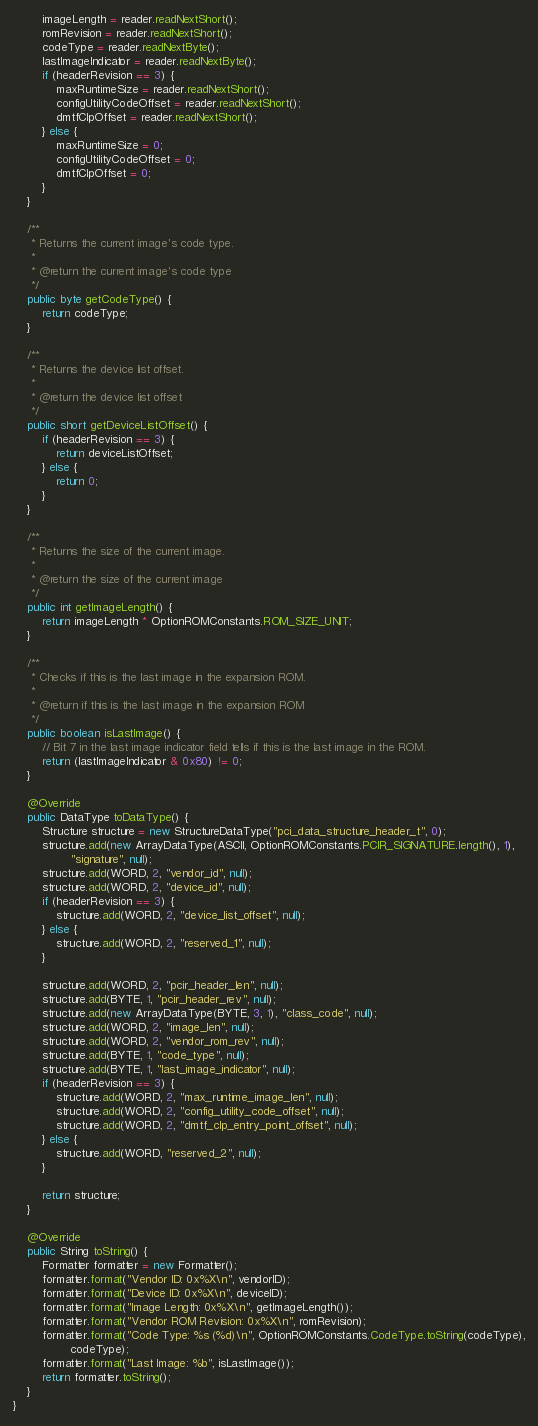Convert code to text. <code><loc_0><loc_0><loc_500><loc_500><_Java_>		imageLength = reader.readNextShort();
		romRevision = reader.readNextShort();
		codeType = reader.readNextByte();
		lastImageIndicator = reader.readNextByte();
		if (headerRevision == 3) {
			maxRuntimeSize = reader.readNextShort();
			configUtilityCodeOffset = reader.readNextShort();
			dmtfClpOffset = reader.readNextShort();
		} else {
			maxRuntimeSize = 0;
			configUtilityCodeOffset = 0;
			dmtfClpOffset = 0;
		}
	}

	/**
	 * Returns the current image's code type.
	 *
	 * @return the current image's code type
	 */
	public byte getCodeType() {
		return codeType;
	}

	/**
	 * Returns the device list offset.
	 *
	 * @return the device list offset
	 */
	public short getDeviceListOffset() {
		if (headerRevision == 3) {
			return deviceListOffset;
		} else {
			return 0;
		}
	}

	/**
	 * Returns the size of the current image.
	 *
	 * @return the size of the current image
	 */
	public int getImageLength() {
		return imageLength * OptionROMConstants.ROM_SIZE_UNIT;
	}

	/**
	 * Checks if this is the last image in the expansion ROM.
	 *
	 * @return if this is the last image in the expansion ROM
	 */
	public boolean isLastImage() {
		// Bit 7 in the last image indicator field tells if this is the last image in the ROM.
		return (lastImageIndicator & 0x80) != 0;
	}

	@Override
	public DataType toDataType() {
		Structure structure = new StructureDataType("pci_data_structure_header_t", 0);
		structure.add(new ArrayDataType(ASCII, OptionROMConstants.PCIR_SIGNATURE.length(), 1),
				"signature", null);
		structure.add(WORD, 2, "vendor_id", null);
		structure.add(WORD, 2, "device_id", null);
		if (headerRevision == 3) {
			structure.add(WORD, 2, "device_list_offset", null);
		} else {
			structure.add(WORD, 2, "reserved_1", null);
		}

		structure.add(WORD, 2, "pcir_header_len", null);
		structure.add(BYTE, 1, "pcir_header_rev", null);
		structure.add(new ArrayDataType(BYTE, 3, 1), "class_code", null);
		structure.add(WORD, 2, "image_len", null);
		structure.add(WORD, 2, "vendor_rom_rev", null);
		structure.add(BYTE, 1, "code_type", null);
		structure.add(BYTE, 1, "last_image_indicator", null);
		if (headerRevision == 3) {
			structure.add(WORD, 2, "max_runtime_image_len", null);
			structure.add(WORD, 2, "config_utility_code_offset", null);
			structure.add(WORD, 2, "dmtf_clp_entry_point_offset", null);
		} else {
			structure.add(WORD, "reserved_2", null);
		}

		return structure;
	}

	@Override
	public String toString() {
		Formatter formatter = new Formatter();
		formatter.format("Vendor ID: 0x%X\n", vendorID);
		formatter.format("Device ID: 0x%X\n", deviceID);
		formatter.format("Image Length: 0x%X\n", getImageLength());
		formatter.format("Vendor ROM Revision: 0x%X\n", romRevision);
		formatter.format("Code Type: %s (%d)\n", OptionROMConstants.CodeType.toString(codeType),
				codeType);
		formatter.format("Last Image: %b", isLastImage());
		return formatter.toString();
	}
}
</code> 